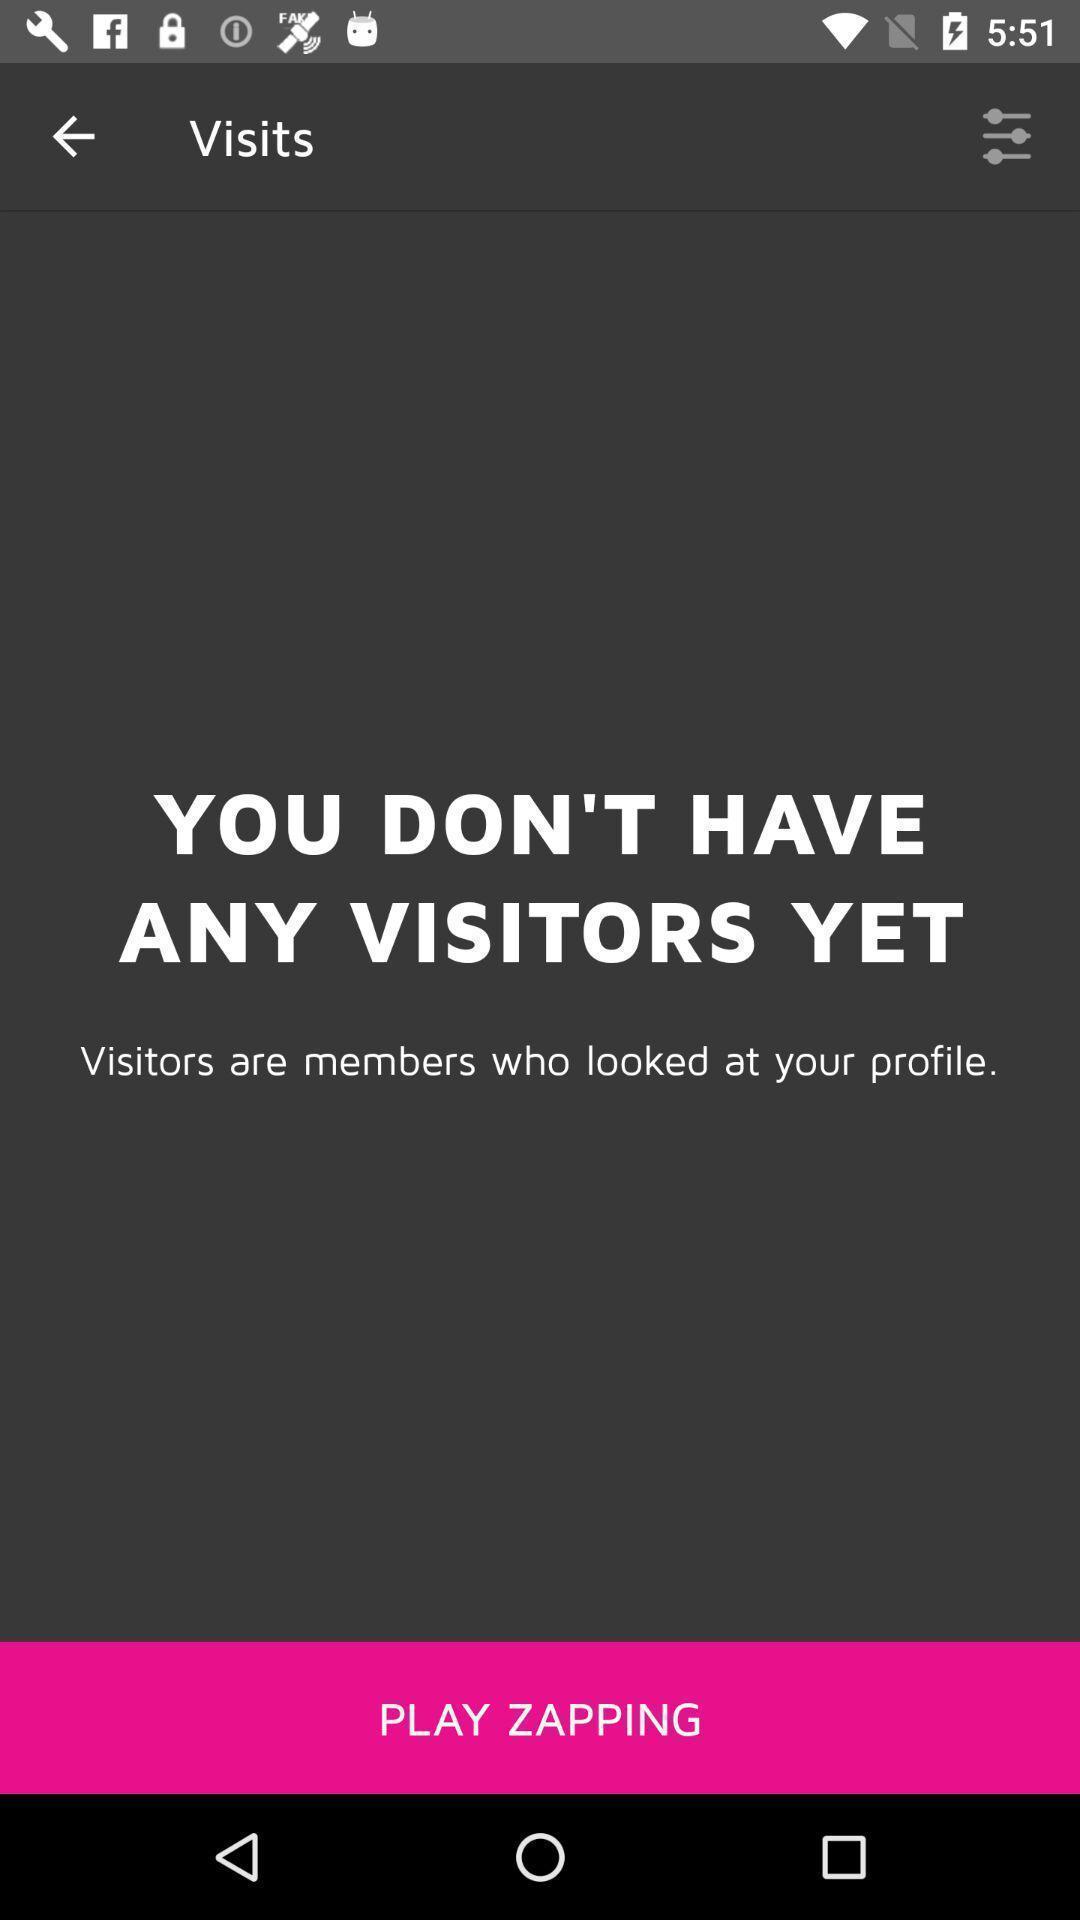What can you discern from this picture? Screen shows visits of members. 